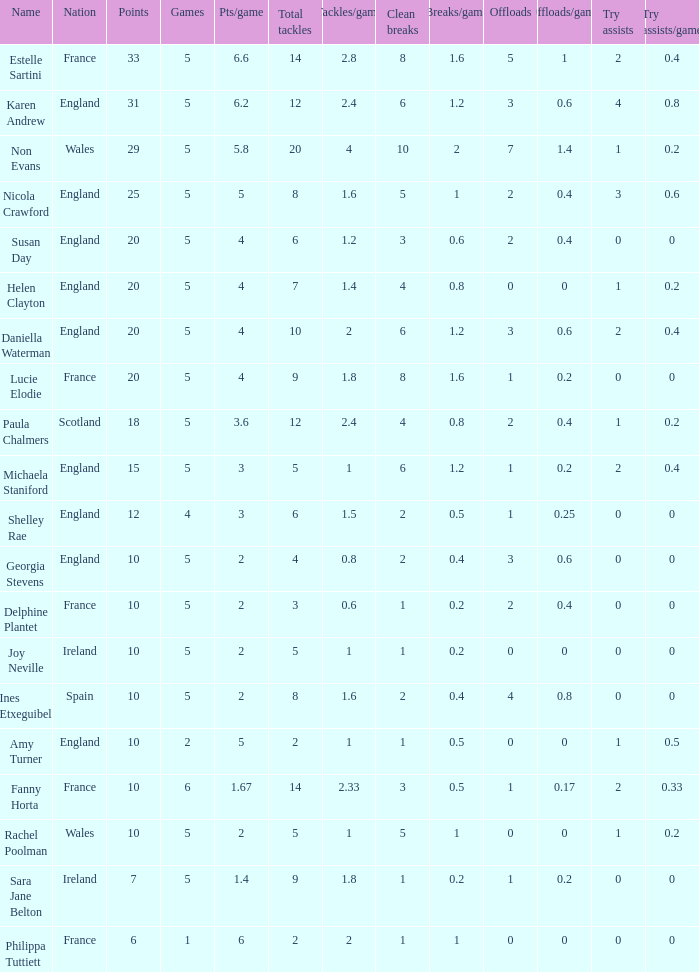Can you tell me the average Points that has a Pts/game larger than 4, and the Nation of england, and the Games smaller than 5? 10.0. 